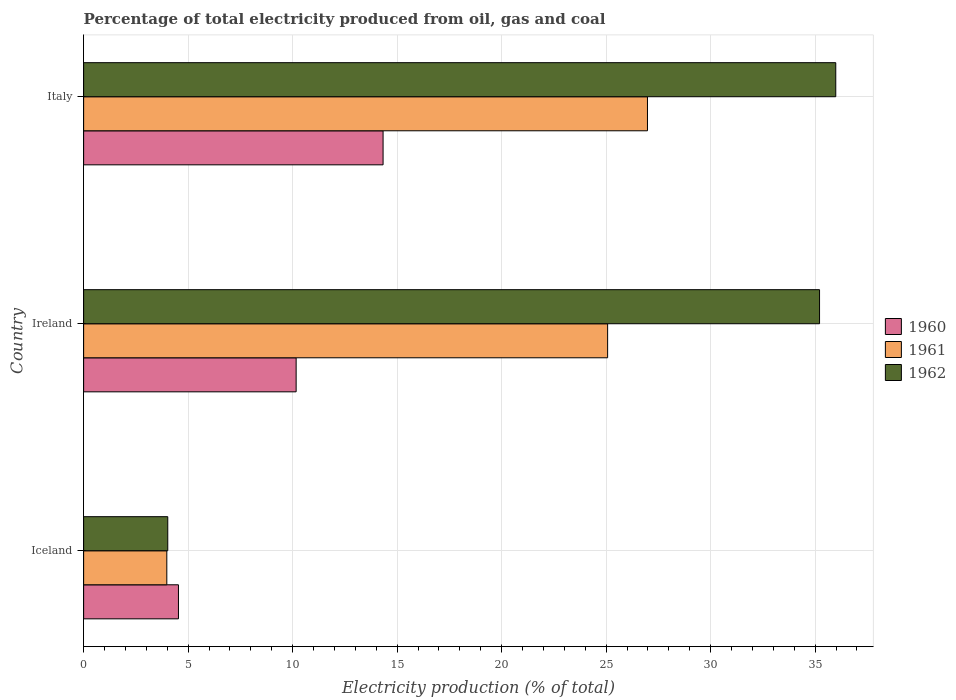How many different coloured bars are there?
Make the answer very short. 3. How many groups of bars are there?
Keep it short and to the point. 3. Are the number of bars per tick equal to the number of legend labels?
Provide a short and direct response. Yes. Are the number of bars on each tick of the Y-axis equal?
Your answer should be compact. Yes. How many bars are there on the 1st tick from the top?
Provide a succinct answer. 3. How many bars are there on the 1st tick from the bottom?
Offer a terse response. 3. What is the label of the 3rd group of bars from the top?
Give a very brief answer. Iceland. What is the electricity production in in 1960 in Ireland?
Offer a very short reply. 10.17. Across all countries, what is the maximum electricity production in in 1962?
Your answer should be compact. 35.99. Across all countries, what is the minimum electricity production in in 1962?
Your answer should be compact. 4.03. In which country was the electricity production in in 1961 maximum?
Provide a succinct answer. Italy. What is the total electricity production in in 1961 in the graph?
Provide a succinct answer. 56.03. What is the difference between the electricity production in in 1962 in Iceland and that in Ireland?
Provide a succinct answer. -31.19. What is the difference between the electricity production in in 1960 in Ireland and the electricity production in in 1961 in Iceland?
Provide a short and direct response. 6.19. What is the average electricity production in in 1962 per country?
Provide a short and direct response. 25.07. What is the difference between the electricity production in in 1961 and electricity production in in 1962 in Italy?
Provide a short and direct response. -9.01. What is the ratio of the electricity production in in 1961 in Iceland to that in Ireland?
Your response must be concise. 0.16. Is the difference between the electricity production in in 1961 in Iceland and Ireland greater than the difference between the electricity production in in 1962 in Iceland and Ireland?
Your answer should be compact. Yes. What is the difference between the highest and the second highest electricity production in in 1961?
Your response must be concise. 1.91. What is the difference between the highest and the lowest electricity production in in 1961?
Your answer should be compact. 23. In how many countries, is the electricity production in in 1962 greater than the average electricity production in in 1962 taken over all countries?
Ensure brevity in your answer.  2. Is the sum of the electricity production in in 1961 in Ireland and Italy greater than the maximum electricity production in in 1960 across all countries?
Your response must be concise. Yes. Is it the case that in every country, the sum of the electricity production in in 1960 and electricity production in in 1962 is greater than the electricity production in in 1961?
Your answer should be compact. Yes. How many countries are there in the graph?
Your response must be concise. 3. What is the difference between two consecutive major ticks on the X-axis?
Provide a short and direct response. 5. Does the graph contain grids?
Your answer should be very brief. Yes. Where does the legend appear in the graph?
Make the answer very short. Center right. How are the legend labels stacked?
Ensure brevity in your answer.  Vertical. What is the title of the graph?
Provide a succinct answer. Percentage of total electricity produced from oil, gas and coal. Does "1967" appear as one of the legend labels in the graph?
Keep it short and to the point. No. What is the label or title of the X-axis?
Make the answer very short. Electricity production (% of total). What is the label or title of the Y-axis?
Your answer should be very brief. Country. What is the Electricity production (% of total) of 1960 in Iceland?
Your answer should be compact. 4.54. What is the Electricity production (% of total) in 1961 in Iceland?
Provide a short and direct response. 3.98. What is the Electricity production (% of total) of 1962 in Iceland?
Your answer should be very brief. 4.03. What is the Electricity production (% of total) in 1960 in Ireland?
Make the answer very short. 10.17. What is the Electricity production (% of total) of 1961 in Ireland?
Ensure brevity in your answer.  25.07. What is the Electricity production (% of total) in 1962 in Ireland?
Provide a succinct answer. 35.21. What is the Electricity production (% of total) in 1960 in Italy?
Make the answer very short. 14.33. What is the Electricity production (% of total) of 1961 in Italy?
Give a very brief answer. 26.98. What is the Electricity production (% of total) of 1962 in Italy?
Offer a very short reply. 35.99. Across all countries, what is the maximum Electricity production (% of total) of 1960?
Offer a terse response. 14.33. Across all countries, what is the maximum Electricity production (% of total) of 1961?
Your response must be concise. 26.98. Across all countries, what is the maximum Electricity production (% of total) of 1962?
Make the answer very short. 35.99. Across all countries, what is the minimum Electricity production (% of total) in 1960?
Provide a succinct answer. 4.54. Across all countries, what is the minimum Electricity production (% of total) in 1961?
Make the answer very short. 3.98. Across all countries, what is the minimum Electricity production (% of total) in 1962?
Make the answer very short. 4.03. What is the total Electricity production (% of total) in 1960 in the graph?
Make the answer very short. 29.03. What is the total Electricity production (% of total) in 1961 in the graph?
Ensure brevity in your answer.  56.03. What is the total Electricity production (% of total) in 1962 in the graph?
Your answer should be very brief. 75.22. What is the difference between the Electricity production (% of total) of 1960 in Iceland and that in Ireland?
Offer a very short reply. -5.63. What is the difference between the Electricity production (% of total) in 1961 in Iceland and that in Ireland?
Your answer should be compact. -21.09. What is the difference between the Electricity production (% of total) in 1962 in Iceland and that in Ireland?
Offer a terse response. -31.19. What is the difference between the Electricity production (% of total) of 1960 in Iceland and that in Italy?
Your response must be concise. -9.79. What is the difference between the Electricity production (% of total) in 1961 in Iceland and that in Italy?
Your response must be concise. -23. What is the difference between the Electricity production (% of total) of 1962 in Iceland and that in Italy?
Offer a very short reply. -31.96. What is the difference between the Electricity production (% of total) in 1960 in Ireland and that in Italy?
Offer a very short reply. -4.16. What is the difference between the Electricity production (% of total) in 1961 in Ireland and that in Italy?
Offer a very short reply. -1.91. What is the difference between the Electricity production (% of total) in 1962 in Ireland and that in Italy?
Give a very brief answer. -0.78. What is the difference between the Electricity production (% of total) of 1960 in Iceland and the Electricity production (% of total) of 1961 in Ireland?
Provide a short and direct response. -20.53. What is the difference between the Electricity production (% of total) in 1960 in Iceland and the Electricity production (% of total) in 1962 in Ireland?
Provide a succinct answer. -30.67. What is the difference between the Electricity production (% of total) of 1961 in Iceland and the Electricity production (% of total) of 1962 in Ireland?
Offer a very short reply. -31.23. What is the difference between the Electricity production (% of total) in 1960 in Iceland and the Electricity production (% of total) in 1961 in Italy?
Your response must be concise. -22.44. What is the difference between the Electricity production (% of total) of 1960 in Iceland and the Electricity production (% of total) of 1962 in Italy?
Offer a very short reply. -31.45. What is the difference between the Electricity production (% of total) in 1961 in Iceland and the Electricity production (% of total) in 1962 in Italy?
Ensure brevity in your answer.  -32.01. What is the difference between the Electricity production (% of total) in 1960 in Ireland and the Electricity production (% of total) in 1961 in Italy?
Make the answer very short. -16.81. What is the difference between the Electricity production (% of total) of 1960 in Ireland and the Electricity production (% of total) of 1962 in Italy?
Your response must be concise. -25.82. What is the difference between the Electricity production (% of total) in 1961 in Ireland and the Electricity production (% of total) in 1962 in Italy?
Keep it short and to the point. -10.92. What is the average Electricity production (% of total) in 1960 per country?
Your response must be concise. 9.68. What is the average Electricity production (% of total) in 1961 per country?
Provide a succinct answer. 18.68. What is the average Electricity production (% of total) in 1962 per country?
Provide a succinct answer. 25.07. What is the difference between the Electricity production (% of total) in 1960 and Electricity production (% of total) in 1961 in Iceland?
Ensure brevity in your answer.  0.56. What is the difference between the Electricity production (% of total) of 1960 and Electricity production (% of total) of 1962 in Iceland?
Provide a succinct answer. 0.51. What is the difference between the Electricity production (% of total) of 1961 and Electricity production (% of total) of 1962 in Iceland?
Offer a terse response. -0.05. What is the difference between the Electricity production (% of total) of 1960 and Electricity production (% of total) of 1961 in Ireland?
Give a very brief answer. -14.9. What is the difference between the Electricity production (% of total) of 1960 and Electricity production (% of total) of 1962 in Ireland?
Provide a succinct answer. -25.04. What is the difference between the Electricity production (% of total) of 1961 and Electricity production (% of total) of 1962 in Ireland?
Make the answer very short. -10.14. What is the difference between the Electricity production (% of total) of 1960 and Electricity production (% of total) of 1961 in Italy?
Your response must be concise. -12.65. What is the difference between the Electricity production (% of total) of 1960 and Electricity production (% of total) of 1962 in Italy?
Your answer should be compact. -21.66. What is the difference between the Electricity production (% of total) in 1961 and Electricity production (% of total) in 1962 in Italy?
Offer a very short reply. -9.01. What is the ratio of the Electricity production (% of total) of 1960 in Iceland to that in Ireland?
Keep it short and to the point. 0.45. What is the ratio of the Electricity production (% of total) in 1961 in Iceland to that in Ireland?
Make the answer very short. 0.16. What is the ratio of the Electricity production (% of total) in 1962 in Iceland to that in Ireland?
Your response must be concise. 0.11. What is the ratio of the Electricity production (% of total) in 1960 in Iceland to that in Italy?
Ensure brevity in your answer.  0.32. What is the ratio of the Electricity production (% of total) of 1961 in Iceland to that in Italy?
Make the answer very short. 0.15. What is the ratio of the Electricity production (% of total) of 1962 in Iceland to that in Italy?
Provide a short and direct response. 0.11. What is the ratio of the Electricity production (% of total) of 1960 in Ireland to that in Italy?
Offer a very short reply. 0.71. What is the ratio of the Electricity production (% of total) in 1961 in Ireland to that in Italy?
Your answer should be very brief. 0.93. What is the ratio of the Electricity production (% of total) of 1962 in Ireland to that in Italy?
Provide a short and direct response. 0.98. What is the difference between the highest and the second highest Electricity production (% of total) in 1960?
Offer a very short reply. 4.16. What is the difference between the highest and the second highest Electricity production (% of total) of 1961?
Give a very brief answer. 1.91. What is the difference between the highest and the second highest Electricity production (% of total) of 1962?
Offer a very short reply. 0.78. What is the difference between the highest and the lowest Electricity production (% of total) of 1960?
Offer a very short reply. 9.79. What is the difference between the highest and the lowest Electricity production (% of total) in 1961?
Provide a short and direct response. 23. What is the difference between the highest and the lowest Electricity production (% of total) of 1962?
Make the answer very short. 31.96. 